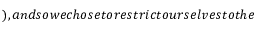<formula> <loc_0><loc_0><loc_500><loc_500>\AA ) , a n d s o w e c h o s e t o r e s t r i c t o u r s e l v e s t o t h e</formula> 